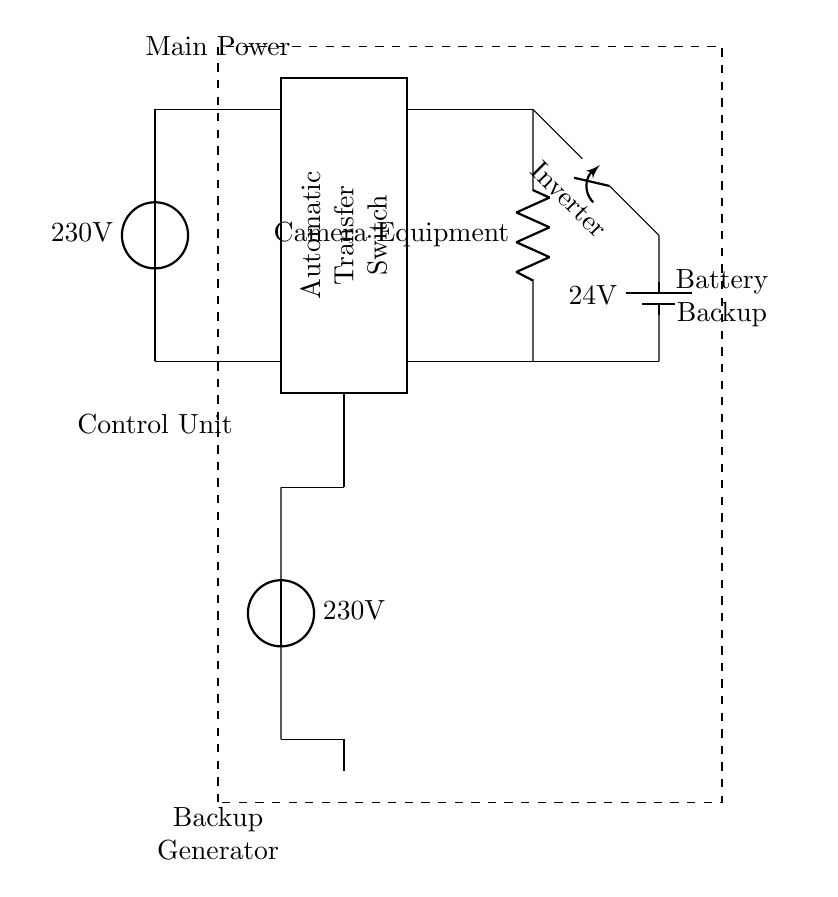What is the main power supply voltage in the circuit? The main power supply voltage is indicated on the voltage source symbol, which states 230 volts.
Answer: 230 volts What is the role of the Automatic Transfer Switch? The Automatic Transfer Switch (ATS) is responsible for switching between the main power supply and the backup generator to ensure seamless power delivery.
Answer: Switching power What component feeds the Camera Equipment with power? The Camera Equipment is powered by the connections from the Automatic Transfer Switch, which leads to the load symbol representing the Camera Equipment.
Answer: Camera Equipment What is the voltage of the battery backup? The battery backup is labeled with a voltage of 24 volts, indicating the potential it supplies when engaged.
Answer: 24 volts How does the inverter connect to the battery backup and the Camera Equipment? The inverter connects to the battery through a closing switch, which then leads directly to the Camera Equipment, allowing it to supply power when the main power is unavailable.
Answer: Through a closing switch What is indicated by the dashed rectangle in the diagram? The dashed rectangle represents the Control Unit, which likely manages the operation of the system, including monitoring and switching functions.
Answer: Control Unit 